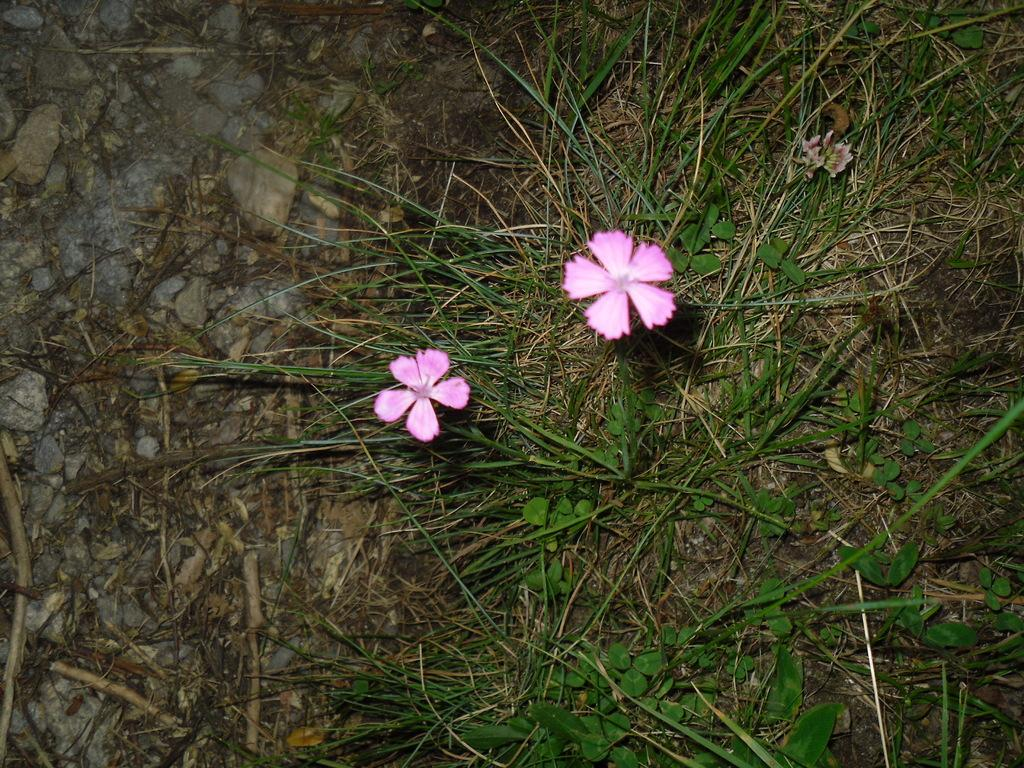What type of plants can be seen in the image? There are flowers in the image. What can be seen in the background of the image? There are stones, grass, and sticks on the ground in the background of the image. What type of engine can be seen in the image? There is no engine present in the image. Where is the lunchroom located in the image? There is no lunchroom present in the image. 